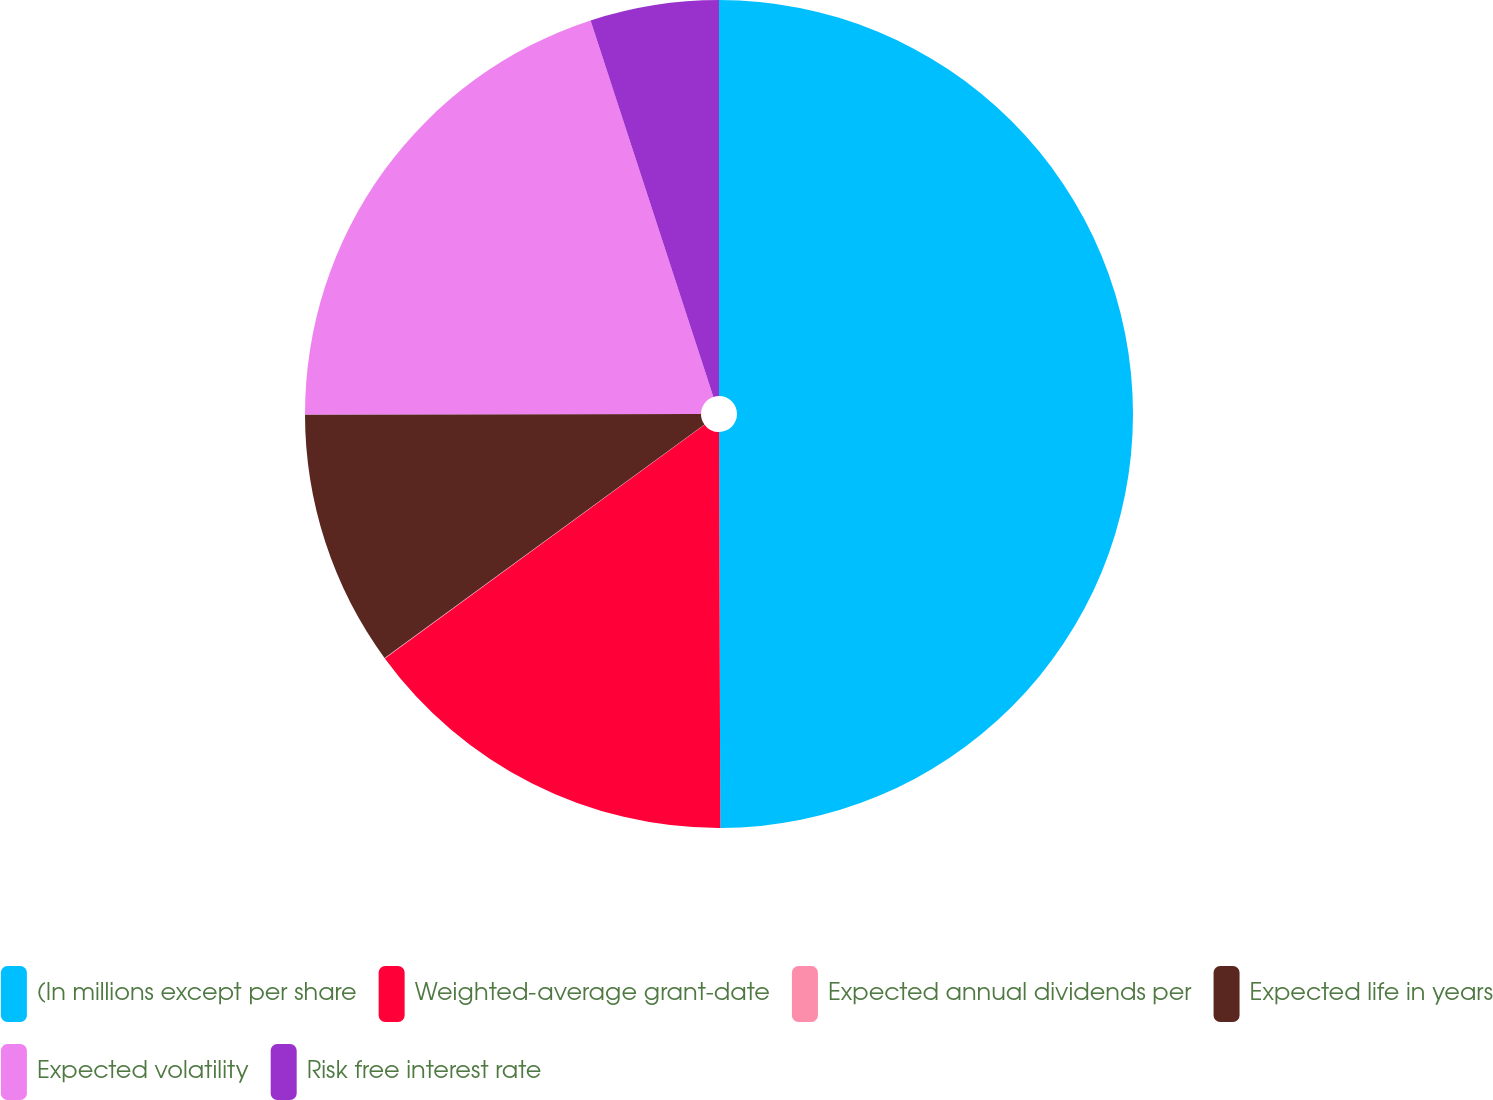<chart> <loc_0><loc_0><loc_500><loc_500><pie_chart><fcel>(In millions except per share<fcel>Weighted-average grant-date<fcel>Expected annual dividends per<fcel>Expected life in years<fcel>Expected volatility<fcel>Risk free interest rate<nl><fcel>49.95%<fcel>15.0%<fcel>0.02%<fcel>10.01%<fcel>20.0%<fcel>5.02%<nl></chart> 